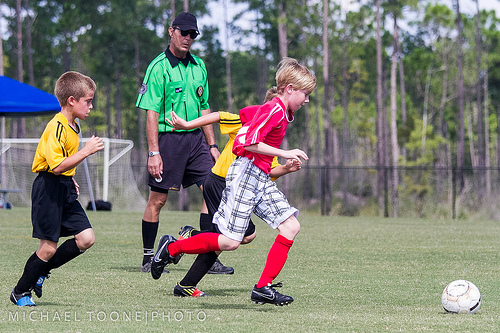<image>
Is the boy in the net? No. The boy is not contained within the net. These objects have a different spatial relationship. Is the ball in front of the kid? Yes. The ball is positioned in front of the kid, appearing closer to the camera viewpoint. 